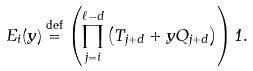Convert formula to latex. <formula><loc_0><loc_0><loc_500><loc_500>E _ { i } ( y ) \stackrel { \text {def} } { = } \left ( \prod _ { j = i } ^ { \ell - d } \left ( T _ { j + d } + y Q _ { j + d } \right ) \right ) 1 .</formula> 